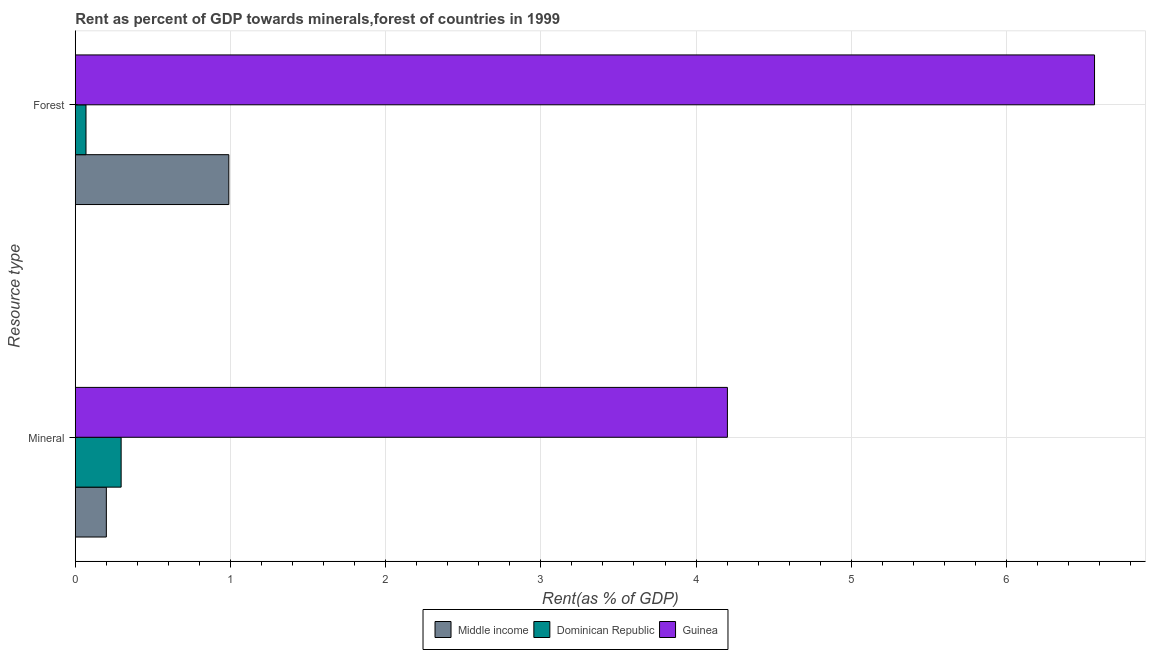How many different coloured bars are there?
Provide a succinct answer. 3. How many groups of bars are there?
Make the answer very short. 2. Are the number of bars per tick equal to the number of legend labels?
Ensure brevity in your answer.  Yes. Are the number of bars on each tick of the Y-axis equal?
Your response must be concise. Yes. How many bars are there on the 1st tick from the top?
Keep it short and to the point. 3. How many bars are there on the 2nd tick from the bottom?
Your response must be concise. 3. What is the label of the 2nd group of bars from the top?
Provide a succinct answer. Mineral. What is the mineral rent in Guinea?
Your answer should be very brief. 4.2. Across all countries, what is the maximum forest rent?
Your answer should be compact. 6.57. Across all countries, what is the minimum forest rent?
Provide a short and direct response. 0.07. In which country was the forest rent maximum?
Make the answer very short. Guinea. In which country was the forest rent minimum?
Offer a very short reply. Dominican Republic. What is the total mineral rent in the graph?
Provide a succinct answer. 4.7. What is the difference between the forest rent in Guinea and that in Dominican Republic?
Your response must be concise. 6.5. What is the difference between the mineral rent in Middle income and the forest rent in Guinea?
Keep it short and to the point. -6.37. What is the average mineral rent per country?
Offer a very short reply. 1.57. What is the difference between the mineral rent and forest rent in Dominican Republic?
Provide a succinct answer. 0.23. In how many countries, is the mineral rent greater than 4.8 %?
Keep it short and to the point. 0. What is the ratio of the forest rent in Middle income to that in Dominican Republic?
Ensure brevity in your answer.  14.36. In how many countries, is the forest rent greater than the average forest rent taken over all countries?
Your answer should be compact. 1. What does the 2nd bar from the top in Forest represents?
Your answer should be compact. Dominican Republic. What does the 3rd bar from the bottom in Mineral represents?
Your answer should be very brief. Guinea. How many bars are there?
Provide a short and direct response. 6. How many countries are there in the graph?
Offer a very short reply. 3. What is the difference between two consecutive major ticks on the X-axis?
Give a very brief answer. 1. Does the graph contain any zero values?
Keep it short and to the point. No. Where does the legend appear in the graph?
Give a very brief answer. Bottom center. How many legend labels are there?
Keep it short and to the point. 3. What is the title of the graph?
Your answer should be very brief. Rent as percent of GDP towards minerals,forest of countries in 1999. Does "Iceland" appear as one of the legend labels in the graph?
Ensure brevity in your answer.  No. What is the label or title of the X-axis?
Offer a very short reply. Rent(as % of GDP). What is the label or title of the Y-axis?
Offer a terse response. Resource type. What is the Rent(as % of GDP) in Middle income in Mineral?
Provide a short and direct response. 0.2. What is the Rent(as % of GDP) in Dominican Republic in Mineral?
Your answer should be very brief. 0.3. What is the Rent(as % of GDP) of Guinea in Mineral?
Give a very brief answer. 4.2. What is the Rent(as % of GDP) in Middle income in Forest?
Your answer should be compact. 0.99. What is the Rent(as % of GDP) in Dominican Republic in Forest?
Offer a terse response. 0.07. What is the Rent(as % of GDP) of Guinea in Forest?
Your answer should be compact. 6.57. Across all Resource type, what is the maximum Rent(as % of GDP) in Middle income?
Your answer should be compact. 0.99. Across all Resource type, what is the maximum Rent(as % of GDP) in Dominican Republic?
Offer a very short reply. 0.3. Across all Resource type, what is the maximum Rent(as % of GDP) of Guinea?
Keep it short and to the point. 6.57. Across all Resource type, what is the minimum Rent(as % of GDP) of Middle income?
Your answer should be compact. 0.2. Across all Resource type, what is the minimum Rent(as % of GDP) of Dominican Republic?
Provide a short and direct response. 0.07. Across all Resource type, what is the minimum Rent(as % of GDP) of Guinea?
Your answer should be compact. 4.2. What is the total Rent(as % of GDP) in Middle income in the graph?
Keep it short and to the point. 1.19. What is the total Rent(as % of GDP) in Dominican Republic in the graph?
Your answer should be compact. 0.36. What is the total Rent(as % of GDP) of Guinea in the graph?
Offer a terse response. 10.77. What is the difference between the Rent(as % of GDP) in Middle income in Mineral and that in Forest?
Provide a succinct answer. -0.79. What is the difference between the Rent(as % of GDP) of Dominican Republic in Mineral and that in Forest?
Offer a terse response. 0.23. What is the difference between the Rent(as % of GDP) of Guinea in Mineral and that in Forest?
Ensure brevity in your answer.  -2.37. What is the difference between the Rent(as % of GDP) of Middle income in Mineral and the Rent(as % of GDP) of Dominican Republic in Forest?
Offer a very short reply. 0.13. What is the difference between the Rent(as % of GDP) of Middle income in Mineral and the Rent(as % of GDP) of Guinea in Forest?
Make the answer very short. -6.37. What is the difference between the Rent(as % of GDP) of Dominican Republic in Mineral and the Rent(as % of GDP) of Guinea in Forest?
Offer a very short reply. -6.27. What is the average Rent(as % of GDP) in Middle income per Resource type?
Offer a terse response. 0.59. What is the average Rent(as % of GDP) in Dominican Republic per Resource type?
Offer a terse response. 0.18. What is the average Rent(as % of GDP) in Guinea per Resource type?
Give a very brief answer. 5.38. What is the difference between the Rent(as % of GDP) of Middle income and Rent(as % of GDP) of Dominican Republic in Mineral?
Make the answer very short. -0.1. What is the difference between the Rent(as % of GDP) of Middle income and Rent(as % of GDP) of Guinea in Mineral?
Ensure brevity in your answer.  -4. What is the difference between the Rent(as % of GDP) in Dominican Republic and Rent(as % of GDP) in Guinea in Mineral?
Make the answer very short. -3.91. What is the difference between the Rent(as % of GDP) of Middle income and Rent(as % of GDP) of Dominican Republic in Forest?
Make the answer very short. 0.92. What is the difference between the Rent(as % of GDP) of Middle income and Rent(as % of GDP) of Guinea in Forest?
Your answer should be compact. -5.58. What is the difference between the Rent(as % of GDP) in Dominican Republic and Rent(as % of GDP) in Guinea in Forest?
Your answer should be compact. -6.5. What is the ratio of the Rent(as % of GDP) in Middle income in Mineral to that in Forest?
Keep it short and to the point. 0.2. What is the ratio of the Rent(as % of GDP) of Dominican Republic in Mineral to that in Forest?
Your response must be concise. 4.29. What is the ratio of the Rent(as % of GDP) in Guinea in Mineral to that in Forest?
Your response must be concise. 0.64. What is the difference between the highest and the second highest Rent(as % of GDP) in Middle income?
Provide a succinct answer. 0.79. What is the difference between the highest and the second highest Rent(as % of GDP) of Dominican Republic?
Offer a terse response. 0.23. What is the difference between the highest and the second highest Rent(as % of GDP) in Guinea?
Give a very brief answer. 2.37. What is the difference between the highest and the lowest Rent(as % of GDP) in Middle income?
Ensure brevity in your answer.  0.79. What is the difference between the highest and the lowest Rent(as % of GDP) in Dominican Republic?
Your response must be concise. 0.23. What is the difference between the highest and the lowest Rent(as % of GDP) of Guinea?
Your answer should be very brief. 2.37. 